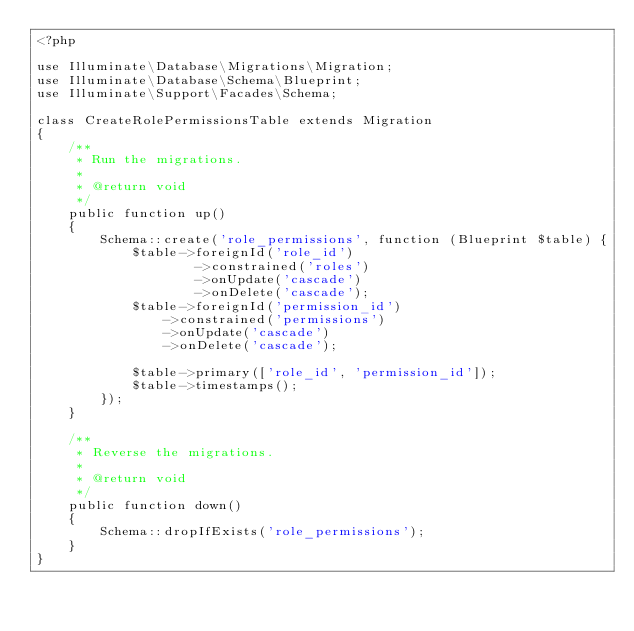<code> <loc_0><loc_0><loc_500><loc_500><_PHP_><?php

use Illuminate\Database\Migrations\Migration;
use Illuminate\Database\Schema\Blueprint;
use Illuminate\Support\Facades\Schema;

class CreateRolePermissionsTable extends Migration
{
    /**
     * Run the migrations.
     *
     * @return void
     */
    public function up()
    {
        Schema::create('role_permissions', function (Blueprint $table) {
            $table->foreignId('role_id')
                    ->constrained('roles')
                    ->onUpdate('cascade')
                    ->onDelete('cascade');
            $table->foreignId('permission_id')
                ->constrained('permissions')
                ->onUpdate('cascade')
                ->onDelete('cascade');

            $table->primary(['role_id', 'permission_id']);
            $table->timestamps();
        });
    }

    /**
     * Reverse the migrations.
     *
     * @return void
     */
    public function down()
    {
        Schema::dropIfExists('role_permissions');
    }
}
</code> 